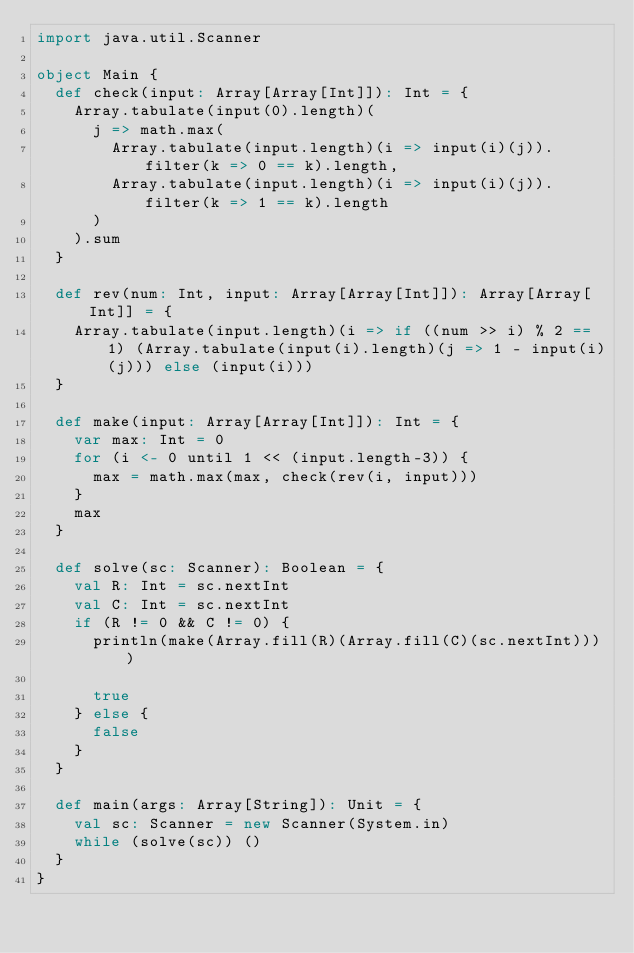<code> <loc_0><loc_0><loc_500><loc_500><_Scala_>import java.util.Scanner

object Main {
  def check(input: Array[Array[Int]]): Int = {
    Array.tabulate(input(0).length)(
      j => math.max(
        Array.tabulate(input.length)(i => input(i)(j)).filter(k => 0 == k).length,
        Array.tabulate(input.length)(i => input(i)(j)).filter(k => 1 == k).length
      )
    ).sum
  }

  def rev(num: Int, input: Array[Array[Int]]): Array[Array[Int]] = {
    Array.tabulate(input.length)(i => if ((num >> i) % 2 == 1) (Array.tabulate(input(i).length)(j => 1 - input(i)(j))) else (input(i)))
  }

  def make(input: Array[Array[Int]]): Int = {
    var max: Int = 0
    for (i <- 0 until 1 << (input.length-3)) {
      max = math.max(max, check(rev(i, input)))
    }
    max
  }

  def solve(sc: Scanner): Boolean = {
    val R: Int = sc.nextInt
    val C: Int = sc.nextInt
    if (R != 0 && C != 0) {
      println(make(Array.fill(R)(Array.fill(C)(sc.nextInt))))

      true
    } else {
      false
    }
  }

  def main(args: Array[String]): Unit = {
    val sc: Scanner = new Scanner(System.in)
    while (solve(sc)) ()
  }
}</code> 